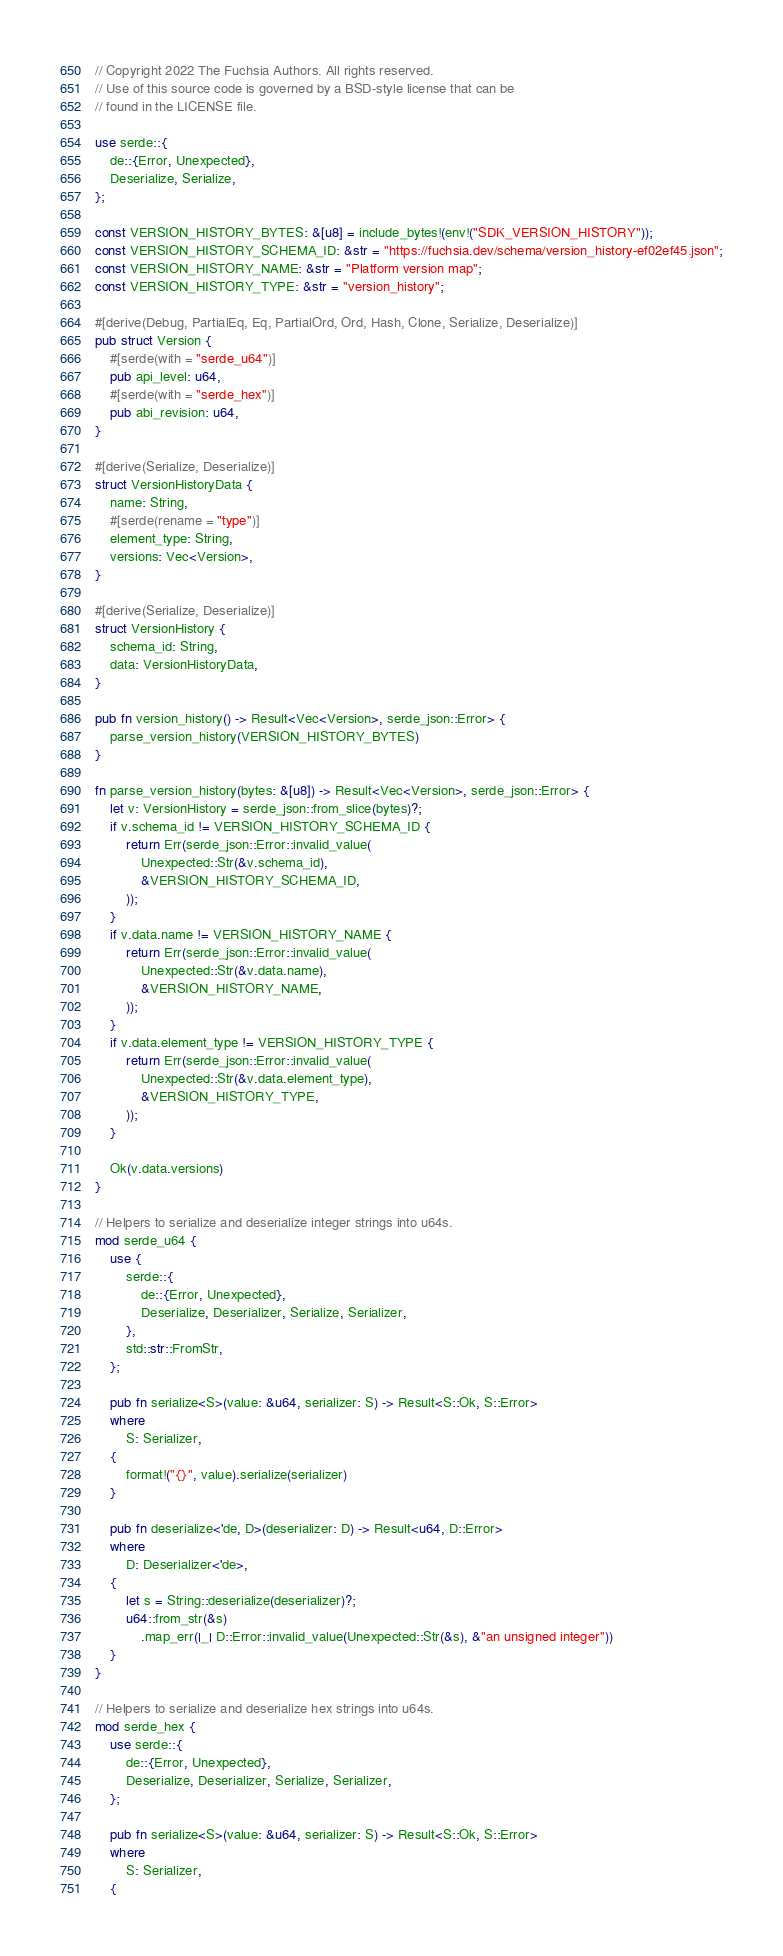<code> <loc_0><loc_0><loc_500><loc_500><_Rust_>// Copyright 2022 The Fuchsia Authors. All rights reserved.
// Use of this source code is governed by a BSD-style license that can be
// found in the LICENSE file.

use serde::{
    de::{Error, Unexpected},
    Deserialize, Serialize,
};

const VERSION_HISTORY_BYTES: &[u8] = include_bytes!(env!("SDK_VERSION_HISTORY"));
const VERSION_HISTORY_SCHEMA_ID: &str = "https://fuchsia.dev/schema/version_history-ef02ef45.json";
const VERSION_HISTORY_NAME: &str = "Platform version map";
const VERSION_HISTORY_TYPE: &str = "version_history";

#[derive(Debug, PartialEq, Eq, PartialOrd, Ord, Hash, Clone, Serialize, Deserialize)]
pub struct Version {
    #[serde(with = "serde_u64")]
    pub api_level: u64,
    #[serde(with = "serde_hex")]
    pub abi_revision: u64,
}

#[derive(Serialize, Deserialize)]
struct VersionHistoryData {
    name: String,
    #[serde(rename = "type")]
    element_type: String,
    versions: Vec<Version>,
}

#[derive(Serialize, Deserialize)]
struct VersionHistory {
    schema_id: String,
    data: VersionHistoryData,
}

pub fn version_history() -> Result<Vec<Version>, serde_json::Error> {
    parse_version_history(VERSION_HISTORY_BYTES)
}

fn parse_version_history(bytes: &[u8]) -> Result<Vec<Version>, serde_json::Error> {
    let v: VersionHistory = serde_json::from_slice(bytes)?;
    if v.schema_id != VERSION_HISTORY_SCHEMA_ID {
        return Err(serde_json::Error::invalid_value(
            Unexpected::Str(&v.schema_id),
            &VERSION_HISTORY_SCHEMA_ID,
        ));
    }
    if v.data.name != VERSION_HISTORY_NAME {
        return Err(serde_json::Error::invalid_value(
            Unexpected::Str(&v.data.name),
            &VERSION_HISTORY_NAME,
        ));
    }
    if v.data.element_type != VERSION_HISTORY_TYPE {
        return Err(serde_json::Error::invalid_value(
            Unexpected::Str(&v.data.element_type),
            &VERSION_HISTORY_TYPE,
        ));
    }

    Ok(v.data.versions)
}

// Helpers to serialize and deserialize integer strings into u64s.
mod serde_u64 {
    use {
        serde::{
            de::{Error, Unexpected},
            Deserialize, Deserializer, Serialize, Serializer,
        },
        std::str::FromStr,
    };

    pub fn serialize<S>(value: &u64, serializer: S) -> Result<S::Ok, S::Error>
    where
        S: Serializer,
    {
        format!("{}", value).serialize(serializer)
    }

    pub fn deserialize<'de, D>(deserializer: D) -> Result<u64, D::Error>
    where
        D: Deserializer<'de>,
    {
        let s = String::deserialize(deserializer)?;
        u64::from_str(&s)
            .map_err(|_| D::Error::invalid_value(Unexpected::Str(&s), &"an unsigned integer"))
    }
}

// Helpers to serialize and deserialize hex strings into u64s.
mod serde_hex {
    use serde::{
        de::{Error, Unexpected},
        Deserialize, Deserializer, Serialize, Serializer,
    };

    pub fn serialize<S>(value: &u64, serializer: S) -> Result<S::Ok, S::Error>
    where
        S: Serializer,
    {</code> 